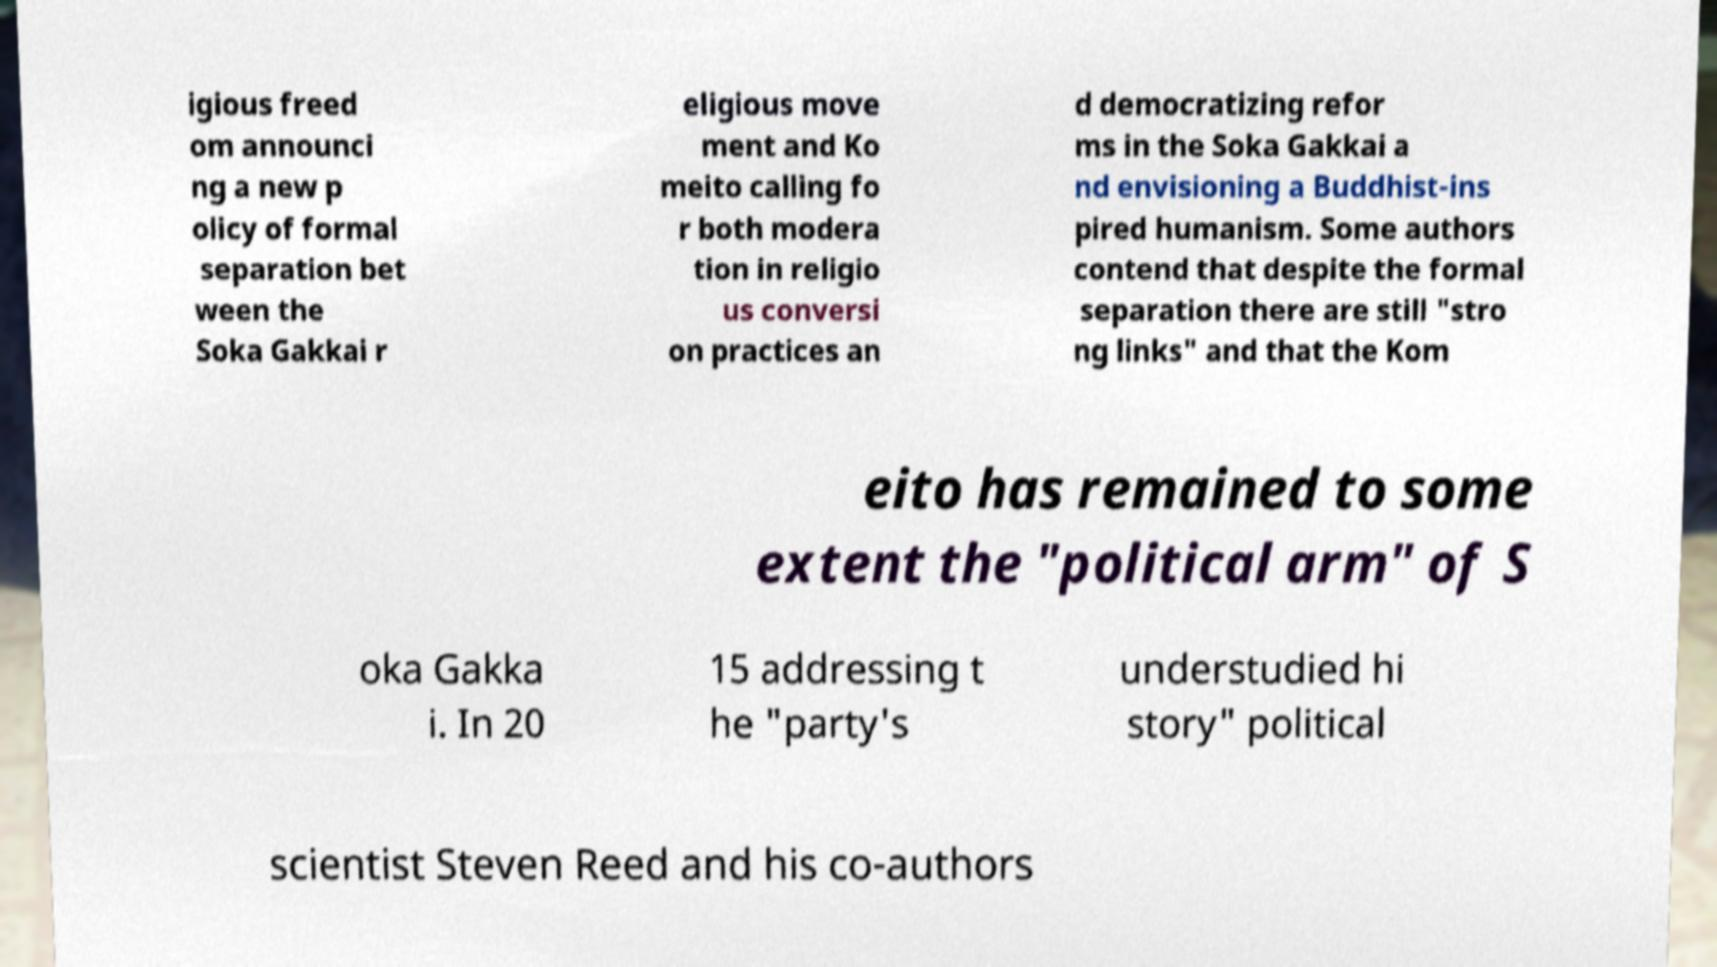Could you assist in decoding the text presented in this image and type it out clearly? igious freed om announci ng a new p olicy of formal separation bet ween the Soka Gakkai r eligious move ment and Ko meito calling fo r both modera tion in religio us conversi on practices an d democratizing refor ms in the Soka Gakkai a nd envisioning a Buddhist-ins pired humanism. Some authors contend that despite the formal separation there are still "stro ng links" and that the Kom eito has remained to some extent the "political arm" of S oka Gakka i. In 20 15 addressing t he "party's understudied hi story" political scientist Steven Reed and his co-authors 